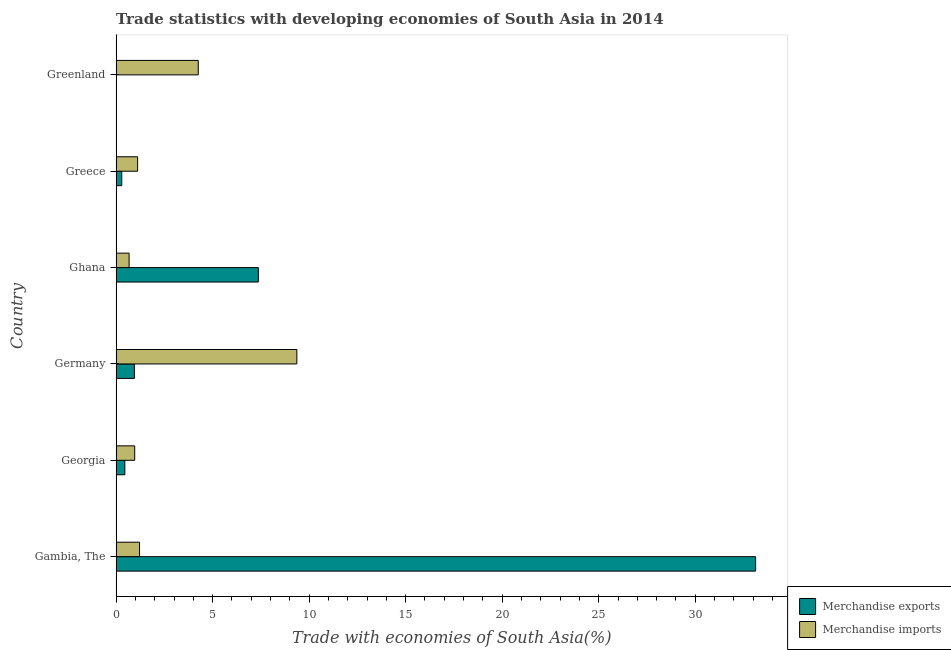How many different coloured bars are there?
Your answer should be very brief. 2. What is the label of the 2nd group of bars from the top?
Your response must be concise. Greece. What is the merchandise imports in Georgia?
Your answer should be very brief. 0.96. Across all countries, what is the maximum merchandise imports?
Your answer should be compact. 9.36. Across all countries, what is the minimum merchandise imports?
Offer a very short reply. 0.67. In which country was the merchandise exports maximum?
Your answer should be compact. Gambia, The. What is the total merchandise imports in the graph?
Make the answer very short. 17.58. What is the difference between the merchandise exports in Georgia and that in Germany?
Give a very brief answer. -0.5. What is the difference between the merchandise exports in Germany and the merchandise imports in Greenland?
Your answer should be compact. -3.31. What is the average merchandise exports per country?
Provide a short and direct response. 7.03. What is the difference between the merchandise imports and merchandise exports in Greenland?
Keep it short and to the point. 4.25. In how many countries, is the merchandise imports greater than 21 %?
Give a very brief answer. 0. What is the ratio of the merchandise imports in Gambia, The to that in Germany?
Provide a short and direct response. 0.13. Is the difference between the merchandise exports in Greece and Greenland greater than the difference between the merchandise imports in Greece and Greenland?
Provide a short and direct response. Yes. What is the difference between the highest and the second highest merchandise exports?
Your response must be concise. 25.76. What is the difference between the highest and the lowest merchandise exports?
Provide a succinct answer. 33.13. What does the 2nd bar from the top in Greece represents?
Offer a terse response. Merchandise exports. What does the 1st bar from the bottom in Ghana represents?
Give a very brief answer. Merchandise exports. How many bars are there?
Give a very brief answer. 12. How many countries are there in the graph?
Offer a terse response. 6. Does the graph contain any zero values?
Give a very brief answer. No. How many legend labels are there?
Offer a very short reply. 2. How are the legend labels stacked?
Your response must be concise. Vertical. What is the title of the graph?
Keep it short and to the point. Trade statistics with developing economies of South Asia in 2014. Does "Age 15+" appear as one of the legend labels in the graph?
Provide a succinct answer. No. What is the label or title of the X-axis?
Keep it short and to the point. Trade with economies of South Asia(%). What is the Trade with economies of South Asia(%) of Merchandise exports in Gambia, The?
Ensure brevity in your answer.  33.13. What is the Trade with economies of South Asia(%) in Merchandise imports in Gambia, The?
Give a very brief answer. 1.21. What is the Trade with economies of South Asia(%) of Merchandise exports in Georgia?
Provide a succinct answer. 0.45. What is the Trade with economies of South Asia(%) of Merchandise imports in Georgia?
Give a very brief answer. 0.96. What is the Trade with economies of South Asia(%) in Merchandise exports in Germany?
Provide a succinct answer. 0.95. What is the Trade with economies of South Asia(%) in Merchandise imports in Germany?
Ensure brevity in your answer.  9.36. What is the Trade with economies of South Asia(%) in Merchandise exports in Ghana?
Your response must be concise. 7.37. What is the Trade with economies of South Asia(%) of Merchandise imports in Ghana?
Give a very brief answer. 0.67. What is the Trade with economies of South Asia(%) in Merchandise exports in Greece?
Your answer should be compact. 0.29. What is the Trade with economies of South Asia(%) in Merchandise imports in Greece?
Make the answer very short. 1.11. What is the Trade with economies of South Asia(%) in Merchandise exports in Greenland?
Offer a terse response. 0. What is the Trade with economies of South Asia(%) in Merchandise imports in Greenland?
Offer a terse response. 4.26. Across all countries, what is the maximum Trade with economies of South Asia(%) of Merchandise exports?
Your answer should be very brief. 33.13. Across all countries, what is the maximum Trade with economies of South Asia(%) of Merchandise imports?
Offer a very short reply. 9.36. Across all countries, what is the minimum Trade with economies of South Asia(%) of Merchandise exports?
Provide a succinct answer. 0. Across all countries, what is the minimum Trade with economies of South Asia(%) in Merchandise imports?
Make the answer very short. 0.67. What is the total Trade with economies of South Asia(%) in Merchandise exports in the graph?
Offer a very short reply. 42.19. What is the total Trade with economies of South Asia(%) of Merchandise imports in the graph?
Your answer should be very brief. 17.58. What is the difference between the Trade with economies of South Asia(%) in Merchandise exports in Gambia, The and that in Georgia?
Keep it short and to the point. 32.68. What is the difference between the Trade with economies of South Asia(%) in Merchandise imports in Gambia, The and that in Georgia?
Offer a very short reply. 0.25. What is the difference between the Trade with economies of South Asia(%) in Merchandise exports in Gambia, The and that in Germany?
Give a very brief answer. 32.18. What is the difference between the Trade with economies of South Asia(%) of Merchandise imports in Gambia, The and that in Germany?
Your response must be concise. -8.15. What is the difference between the Trade with economies of South Asia(%) in Merchandise exports in Gambia, The and that in Ghana?
Provide a short and direct response. 25.76. What is the difference between the Trade with economies of South Asia(%) of Merchandise imports in Gambia, The and that in Ghana?
Your answer should be very brief. 0.54. What is the difference between the Trade with economies of South Asia(%) in Merchandise exports in Gambia, The and that in Greece?
Keep it short and to the point. 32.84. What is the difference between the Trade with economies of South Asia(%) in Merchandise imports in Gambia, The and that in Greece?
Keep it short and to the point. 0.1. What is the difference between the Trade with economies of South Asia(%) of Merchandise exports in Gambia, The and that in Greenland?
Your response must be concise. 33.13. What is the difference between the Trade with economies of South Asia(%) of Merchandise imports in Gambia, The and that in Greenland?
Give a very brief answer. -3.04. What is the difference between the Trade with economies of South Asia(%) in Merchandise exports in Georgia and that in Germany?
Offer a terse response. -0.5. What is the difference between the Trade with economies of South Asia(%) in Merchandise imports in Georgia and that in Germany?
Offer a very short reply. -8.4. What is the difference between the Trade with economies of South Asia(%) in Merchandise exports in Georgia and that in Ghana?
Your answer should be very brief. -6.92. What is the difference between the Trade with economies of South Asia(%) of Merchandise imports in Georgia and that in Ghana?
Provide a succinct answer. 0.29. What is the difference between the Trade with economies of South Asia(%) in Merchandise exports in Georgia and that in Greece?
Provide a succinct answer. 0.16. What is the difference between the Trade with economies of South Asia(%) of Merchandise imports in Georgia and that in Greece?
Provide a short and direct response. -0.15. What is the difference between the Trade with economies of South Asia(%) in Merchandise exports in Georgia and that in Greenland?
Make the answer very short. 0.45. What is the difference between the Trade with economies of South Asia(%) of Merchandise imports in Georgia and that in Greenland?
Provide a short and direct response. -3.29. What is the difference between the Trade with economies of South Asia(%) in Merchandise exports in Germany and that in Ghana?
Provide a short and direct response. -6.42. What is the difference between the Trade with economies of South Asia(%) in Merchandise imports in Germany and that in Ghana?
Give a very brief answer. 8.69. What is the difference between the Trade with economies of South Asia(%) of Merchandise exports in Germany and that in Greece?
Keep it short and to the point. 0.66. What is the difference between the Trade with economies of South Asia(%) in Merchandise imports in Germany and that in Greece?
Offer a terse response. 8.25. What is the difference between the Trade with economies of South Asia(%) of Merchandise exports in Germany and that in Greenland?
Ensure brevity in your answer.  0.95. What is the difference between the Trade with economies of South Asia(%) of Merchandise imports in Germany and that in Greenland?
Give a very brief answer. 5.11. What is the difference between the Trade with economies of South Asia(%) in Merchandise exports in Ghana and that in Greece?
Your answer should be very brief. 7.08. What is the difference between the Trade with economies of South Asia(%) of Merchandise imports in Ghana and that in Greece?
Give a very brief answer. -0.44. What is the difference between the Trade with economies of South Asia(%) of Merchandise exports in Ghana and that in Greenland?
Offer a terse response. 7.37. What is the difference between the Trade with economies of South Asia(%) in Merchandise imports in Ghana and that in Greenland?
Provide a short and direct response. -3.58. What is the difference between the Trade with economies of South Asia(%) in Merchandise exports in Greece and that in Greenland?
Keep it short and to the point. 0.29. What is the difference between the Trade with economies of South Asia(%) in Merchandise imports in Greece and that in Greenland?
Your answer should be compact. -3.14. What is the difference between the Trade with economies of South Asia(%) in Merchandise exports in Gambia, The and the Trade with economies of South Asia(%) in Merchandise imports in Georgia?
Provide a short and direct response. 32.17. What is the difference between the Trade with economies of South Asia(%) in Merchandise exports in Gambia, The and the Trade with economies of South Asia(%) in Merchandise imports in Germany?
Your answer should be very brief. 23.77. What is the difference between the Trade with economies of South Asia(%) of Merchandise exports in Gambia, The and the Trade with economies of South Asia(%) of Merchandise imports in Ghana?
Provide a succinct answer. 32.46. What is the difference between the Trade with economies of South Asia(%) of Merchandise exports in Gambia, The and the Trade with economies of South Asia(%) of Merchandise imports in Greece?
Your answer should be very brief. 32.02. What is the difference between the Trade with economies of South Asia(%) of Merchandise exports in Gambia, The and the Trade with economies of South Asia(%) of Merchandise imports in Greenland?
Offer a terse response. 28.87. What is the difference between the Trade with economies of South Asia(%) in Merchandise exports in Georgia and the Trade with economies of South Asia(%) in Merchandise imports in Germany?
Provide a short and direct response. -8.91. What is the difference between the Trade with economies of South Asia(%) of Merchandise exports in Georgia and the Trade with economies of South Asia(%) of Merchandise imports in Ghana?
Keep it short and to the point. -0.22. What is the difference between the Trade with economies of South Asia(%) of Merchandise exports in Georgia and the Trade with economies of South Asia(%) of Merchandise imports in Greece?
Provide a succinct answer. -0.66. What is the difference between the Trade with economies of South Asia(%) of Merchandise exports in Georgia and the Trade with economies of South Asia(%) of Merchandise imports in Greenland?
Give a very brief answer. -3.8. What is the difference between the Trade with economies of South Asia(%) of Merchandise exports in Germany and the Trade with economies of South Asia(%) of Merchandise imports in Ghana?
Your answer should be very brief. 0.28. What is the difference between the Trade with economies of South Asia(%) in Merchandise exports in Germany and the Trade with economies of South Asia(%) in Merchandise imports in Greece?
Your answer should be compact. -0.17. What is the difference between the Trade with economies of South Asia(%) of Merchandise exports in Germany and the Trade with economies of South Asia(%) of Merchandise imports in Greenland?
Offer a very short reply. -3.31. What is the difference between the Trade with economies of South Asia(%) of Merchandise exports in Ghana and the Trade with economies of South Asia(%) of Merchandise imports in Greece?
Keep it short and to the point. 6.26. What is the difference between the Trade with economies of South Asia(%) in Merchandise exports in Ghana and the Trade with economies of South Asia(%) in Merchandise imports in Greenland?
Your response must be concise. 3.11. What is the difference between the Trade with economies of South Asia(%) in Merchandise exports in Greece and the Trade with economies of South Asia(%) in Merchandise imports in Greenland?
Your response must be concise. -3.96. What is the average Trade with economies of South Asia(%) in Merchandise exports per country?
Provide a succinct answer. 7.03. What is the average Trade with economies of South Asia(%) of Merchandise imports per country?
Make the answer very short. 2.93. What is the difference between the Trade with economies of South Asia(%) in Merchandise exports and Trade with economies of South Asia(%) in Merchandise imports in Gambia, The?
Provide a short and direct response. 31.92. What is the difference between the Trade with economies of South Asia(%) in Merchandise exports and Trade with economies of South Asia(%) in Merchandise imports in Georgia?
Provide a short and direct response. -0.51. What is the difference between the Trade with economies of South Asia(%) in Merchandise exports and Trade with economies of South Asia(%) in Merchandise imports in Germany?
Provide a succinct answer. -8.41. What is the difference between the Trade with economies of South Asia(%) in Merchandise exports and Trade with economies of South Asia(%) in Merchandise imports in Ghana?
Provide a succinct answer. 6.7. What is the difference between the Trade with economies of South Asia(%) in Merchandise exports and Trade with economies of South Asia(%) in Merchandise imports in Greece?
Your response must be concise. -0.82. What is the difference between the Trade with economies of South Asia(%) in Merchandise exports and Trade with economies of South Asia(%) in Merchandise imports in Greenland?
Give a very brief answer. -4.25. What is the ratio of the Trade with economies of South Asia(%) of Merchandise exports in Gambia, The to that in Georgia?
Ensure brevity in your answer.  73.39. What is the ratio of the Trade with economies of South Asia(%) in Merchandise imports in Gambia, The to that in Georgia?
Keep it short and to the point. 1.26. What is the ratio of the Trade with economies of South Asia(%) in Merchandise exports in Gambia, The to that in Germany?
Your answer should be very brief. 34.97. What is the ratio of the Trade with economies of South Asia(%) of Merchandise imports in Gambia, The to that in Germany?
Provide a short and direct response. 0.13. What is the ratio of the Trade with economies of South Asia(%) of Merchandise exports in Gambia, The to that in Ghana?
Keep it short and to the point. 4.5. What is the ratio of the Trade with economies of South Asia(%) in Merchandise imports in Gambia, The to that in Ghana?
Make the answer very short. 1.81. What is the ratio of the Trade with economies of South Asia(%) of Merchandise exports in Gambia, The to that in Greece?
Make the answer very short. 113.44. What is the ratio of the Trade with economies of South Asia(%) of Merchandise imports in Gambia, The to that in Greece?
Offer a terse response. 1.09. What is the ratio of the Trade with economies of South Asia(%) in Merchandise exports in Gambia, The to that in Greenland?
Keep it short and to the point. 1.69e+05. What is the ratio of the Trade with economies of South Asia(%) of Merchandise imports in Gambia, The to that in Greenland?
Offer a very short reply. 0.28. What is the ratio of the Trade with economies of South Asia(%) of Merchandise exports in Georgia to that in Germany?
Offer a very short reply. 0.48. What is the ratio of the Trade with economies of South Asia(%) of Merchandise imports in Georgia to that in Germany?
Provide a succinct answer. 0.1. What is the ratio of the Trade with economies of South Asia(%) of Merchandise exports in Georgia to that in Ghana?
Your answer should be very brief. 0.06. What is the ratio of the Trade with economies of South Asia(%) of Merchandise imports in Georgia to that in Ghana?
Your response must be concise. 1.43. What is the ratio of the Trade with economies of South Asia(%) of Merchandise exports in Georgia to that in Greece?
Ensure brevity in your answer.  1.55. What is the ratio of the Trade with economies of South Asia(%) of Merchandise imports in Georgia to that in Greece?
Offer a very short reply. 0.86. What is the ratio of the Trade with economies of South Asia(%) in Merchandise exports in Georgia to that in Greenland?
Offer a terse response. 2302.69. What is the ratio of the Trade with economies of South Asia(%) in Merchandise imports in Georgia to that in Greenland?
Provide a short and direct response. 0.23. What is the ratio of the Trade with economies of South Asia(%) of Merchandise exports in Germany to that in Ghana?
Give a very brief answer. 0.13. What is the ratio of the Trade with economies of South Asia(%) in Merchandise imports in Germany to that in Ghana?
Your answer should be very brief. 13.94. What is the ratio of the Trade with economies of South Asia(%) in Merchandise exports in Germany to that in Greece?
Keep it short and to the point. 3.24. What is the ratio of the Trade with economies of South Asia(%) of Merchandise imports in Germany to that in Greece?
Ensure brevity in your answer.  8.41. What is the ratio of the Trade with economies of South Asia(%) in Merchandise exports in Germany to that in Greenland?
Ensure brevity in your answer.  4832.96. What is the ratio of the Trade with economies of South Asia(%) in Merchandise imports in Germany to that in Greenland?
Provide a short and direct response. 2.2. What is the ratio of the Trade with economies of South Asia(%) in Merchandise exports in Ghana to that in Greece?
Your answer should be very brief. 25.23. What is the ratio of the Trade with economies of South Asia(%) of Merchandise imports in Ghana to that in Greece?
Provide a short and direct response. 0.6. What is the ratio of the Trade with economies of South Asia(%) of Merchandise exports in Ghana to that in Greenland?
Provide a short and direct response. 3.76e+04. What is the ratio of the Trade with economies of South Asia(%) in Merchandise imports in Ghana to that in Greenland?
Your answer should be very brief. 0.16. What is the ratio of the Trade with economies of South Asia(%) of Merchandise exports in Greece to that in Greenland?
Make the answer very short. 1489.72. What is the ratio of the Trade with economies of South Asia(%) in Merchandise imports in Greece to that in Greenland?
Your response must be concise. 0.26. What is the difference between the highest and the second highest Trade with economies of South Asia(%) of Merchandise exports?
Your answer should be very brief. 25.76. What is the difference between the highest and the second highest Trade with economies of South Asia(%) of Merchandise imports?
Keep it short and to the point. 5.11. What is the difference between the highest and the lowest Trade with economies of South Asia(%) in Merchandise exports?
Provide a short and direct response. 33.13. What is the difference between the highest and the lowest Trade with economies of South Asia(%) in Merchandise imports?
Keep it short and to the point. 8.69. 